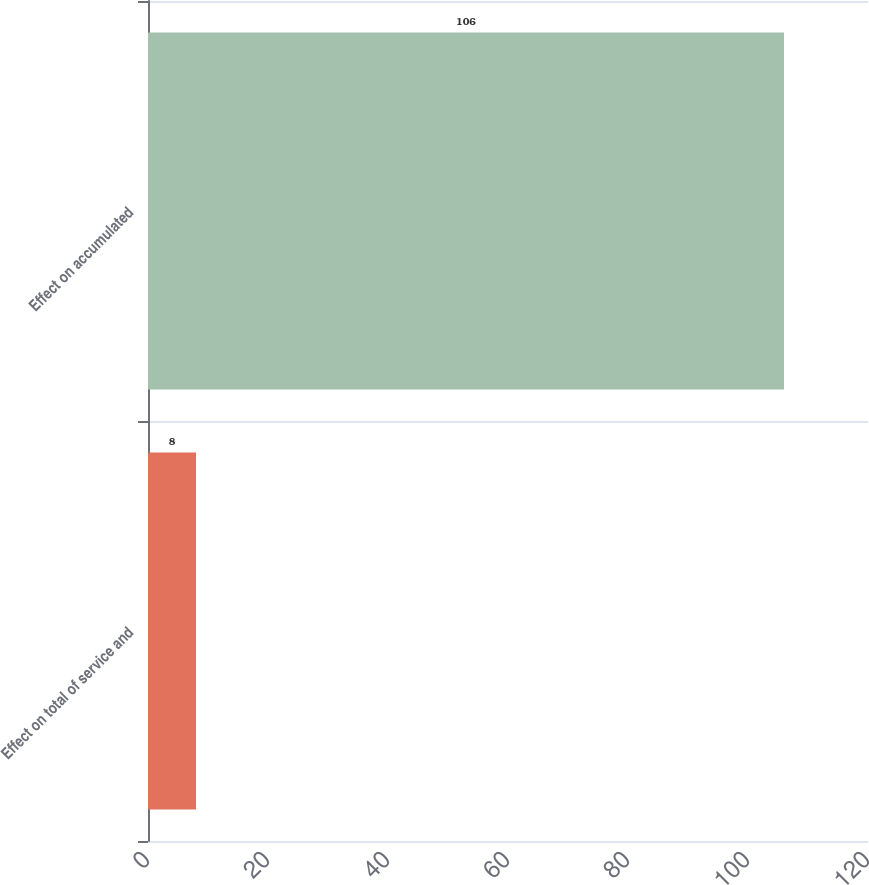<chart> <loc_0><loc_0><loc_500><loc_500><bar_chart><fcel>Effect on total of service and<fcel>Effect on accumulated<nl><fcel>8<fcel>106<nl></chart> 